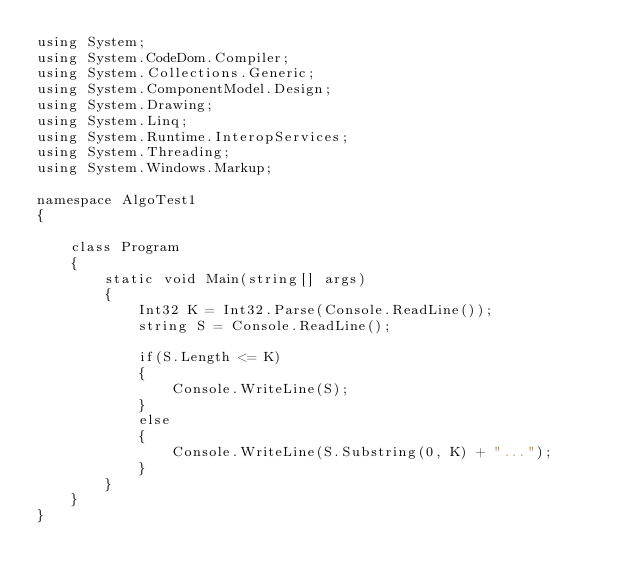<code> <loc_0><loc_0><loc_500><loc_500><_C#_>using System;
using System.CodeDom.Compiler;
using System.Collections.Generic;
using System.ComponentModel.Design;
using System.Drawing;
using System.Linq;
using System.Runtime.InteropServices;
using System.Threading;
using System.Windows.Markup;

namespace AlgoTest1
{

    class Program
    {
        static void Main(string[] args)
        {
            Int32 K = Int32.Parse(Console.ReadLine());
            string S = Console.ReadLine();

            if(S.Length <= K)
            {
                Console.WriteLine(S);
            }
            else
            {
                Console.WriteLine(S.Substring(0, K) + "...");
            }
        }
    }
}</code> 